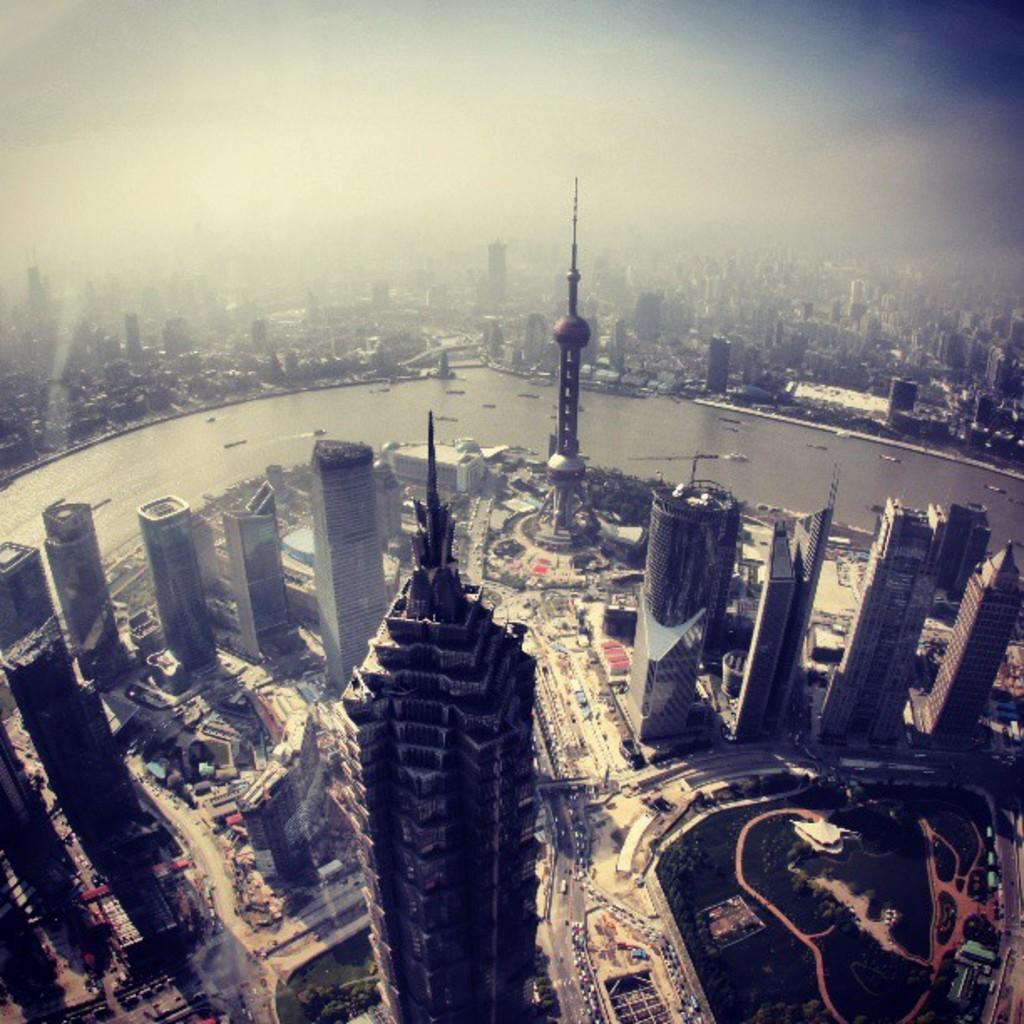Could you give a brief overview of what you see in this image? In this picture I can see there are few streets, buildings and there are few vehicles moving on the street, there are trees, there is a tower and there is a lake here. In the backdrop at the other side of the lake, there are few more buildings and the sky is clear. 